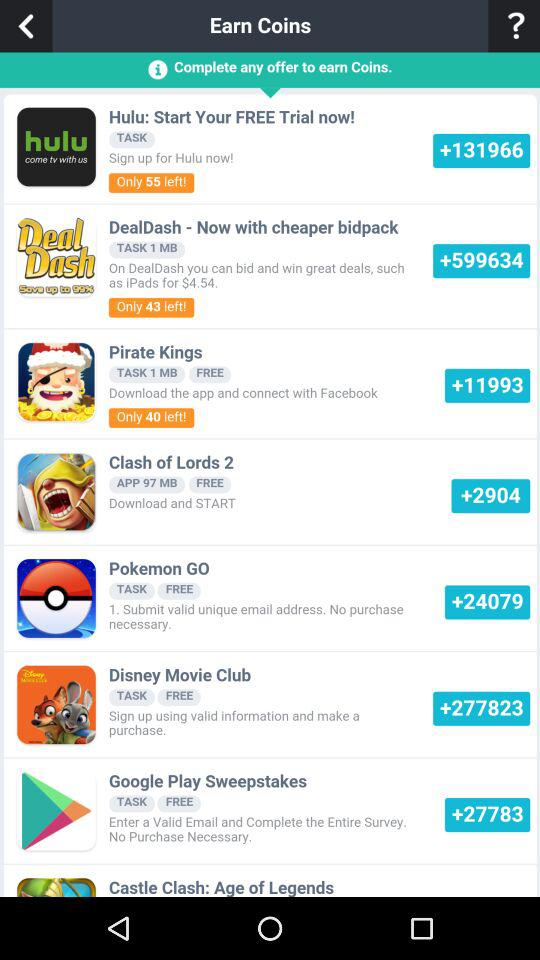What is the name of the application? The names of the applications are "Hulu: Start Your FREE Trial now!", "DealDash - Now with cheaper bidpack", "Pirate Kings", "Clash of Lords 2", "Pokemon GO", "Disney Movie Club", "Google Play Sweepstakes" and "Castle Clash: Age of Legends". 